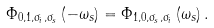<formula> <loc_0><loc_0><loc_500><loc_500>\Phi _ { 0 , 1 , \sigma _ { i } , \sigma _ { s } } \left ( - \omega _ { s } \right ) = \Phi _ { 1 , 0 , \sigma _ { s } , \sigma _ { i } } \left ( \omega _ { s } \right ) .</formula> 